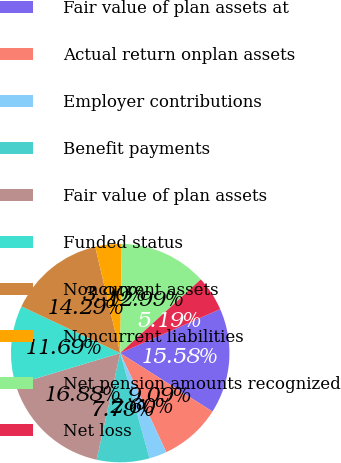Convert chart to OTSL. <chart><loc_0><loc_0><loc_500><loc_500><pie_chart><fcel>Fair value of plan assets at<fcel>Actual return onplan assets<fcel>Employer contributions<fcel>Benefit payments<fcel>Fair value of plan assets<fcel>Funded status<fcel>Noncurrent assets<fcel>Noncurrent liabilities<fcel>Net pension amounts recognized<fcel>Net loss<nl><fcel>15.58%<fcel>9.09%<fcel>2.6%<fcel>7.79%<fcel>16.88%<fcel>11.69%<fcel>14.29%<fcel>3.9%<fcel>12.99%<fcel>5.19%<nl></chart> 